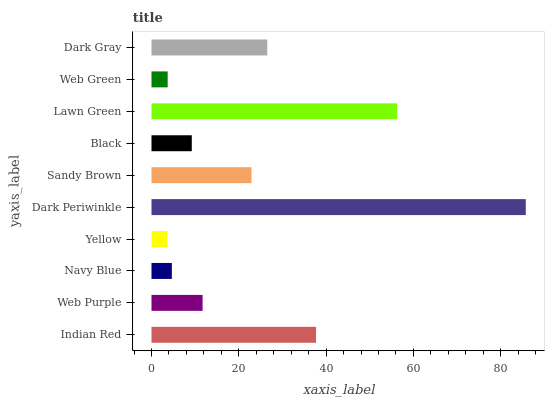Is Yellow the minimum?
Answer yes or no. Yes. Is Dark Periwinkle the maximum?
Answer yes or no. Yes. Is Web Purple the minimum?
Answer yes or no. No. Is Web Purple the maximum?
Answer yes or no. No. Is Indian Red greater than Web Purple?
Answer yes or no. Yes. Is Web Purple less than Indian Red?
Answer yes or no. Yes. Is Web Purple greater than Indian Red?
Answer yes or no. No. Is Indian Red less than Web Purple?
Answer yes or no. No. Is Sandy Brown the high median?
Answer yes or no. Yes. Is Web Purple the low median?
Answer yes or no. Yes. Is Navy Blue the high median?
Answer yes or no. No. Is Lawn Green the low median?
Answer yes or no. No. 